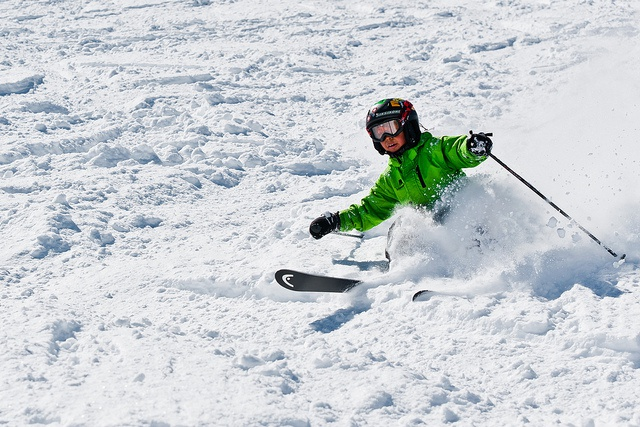Describe the objects in this image and their specific colors. I can see people in darkgray, darkgreen, black, green, and gray tones and skis in darkgray, black, and gray tones in this image. 